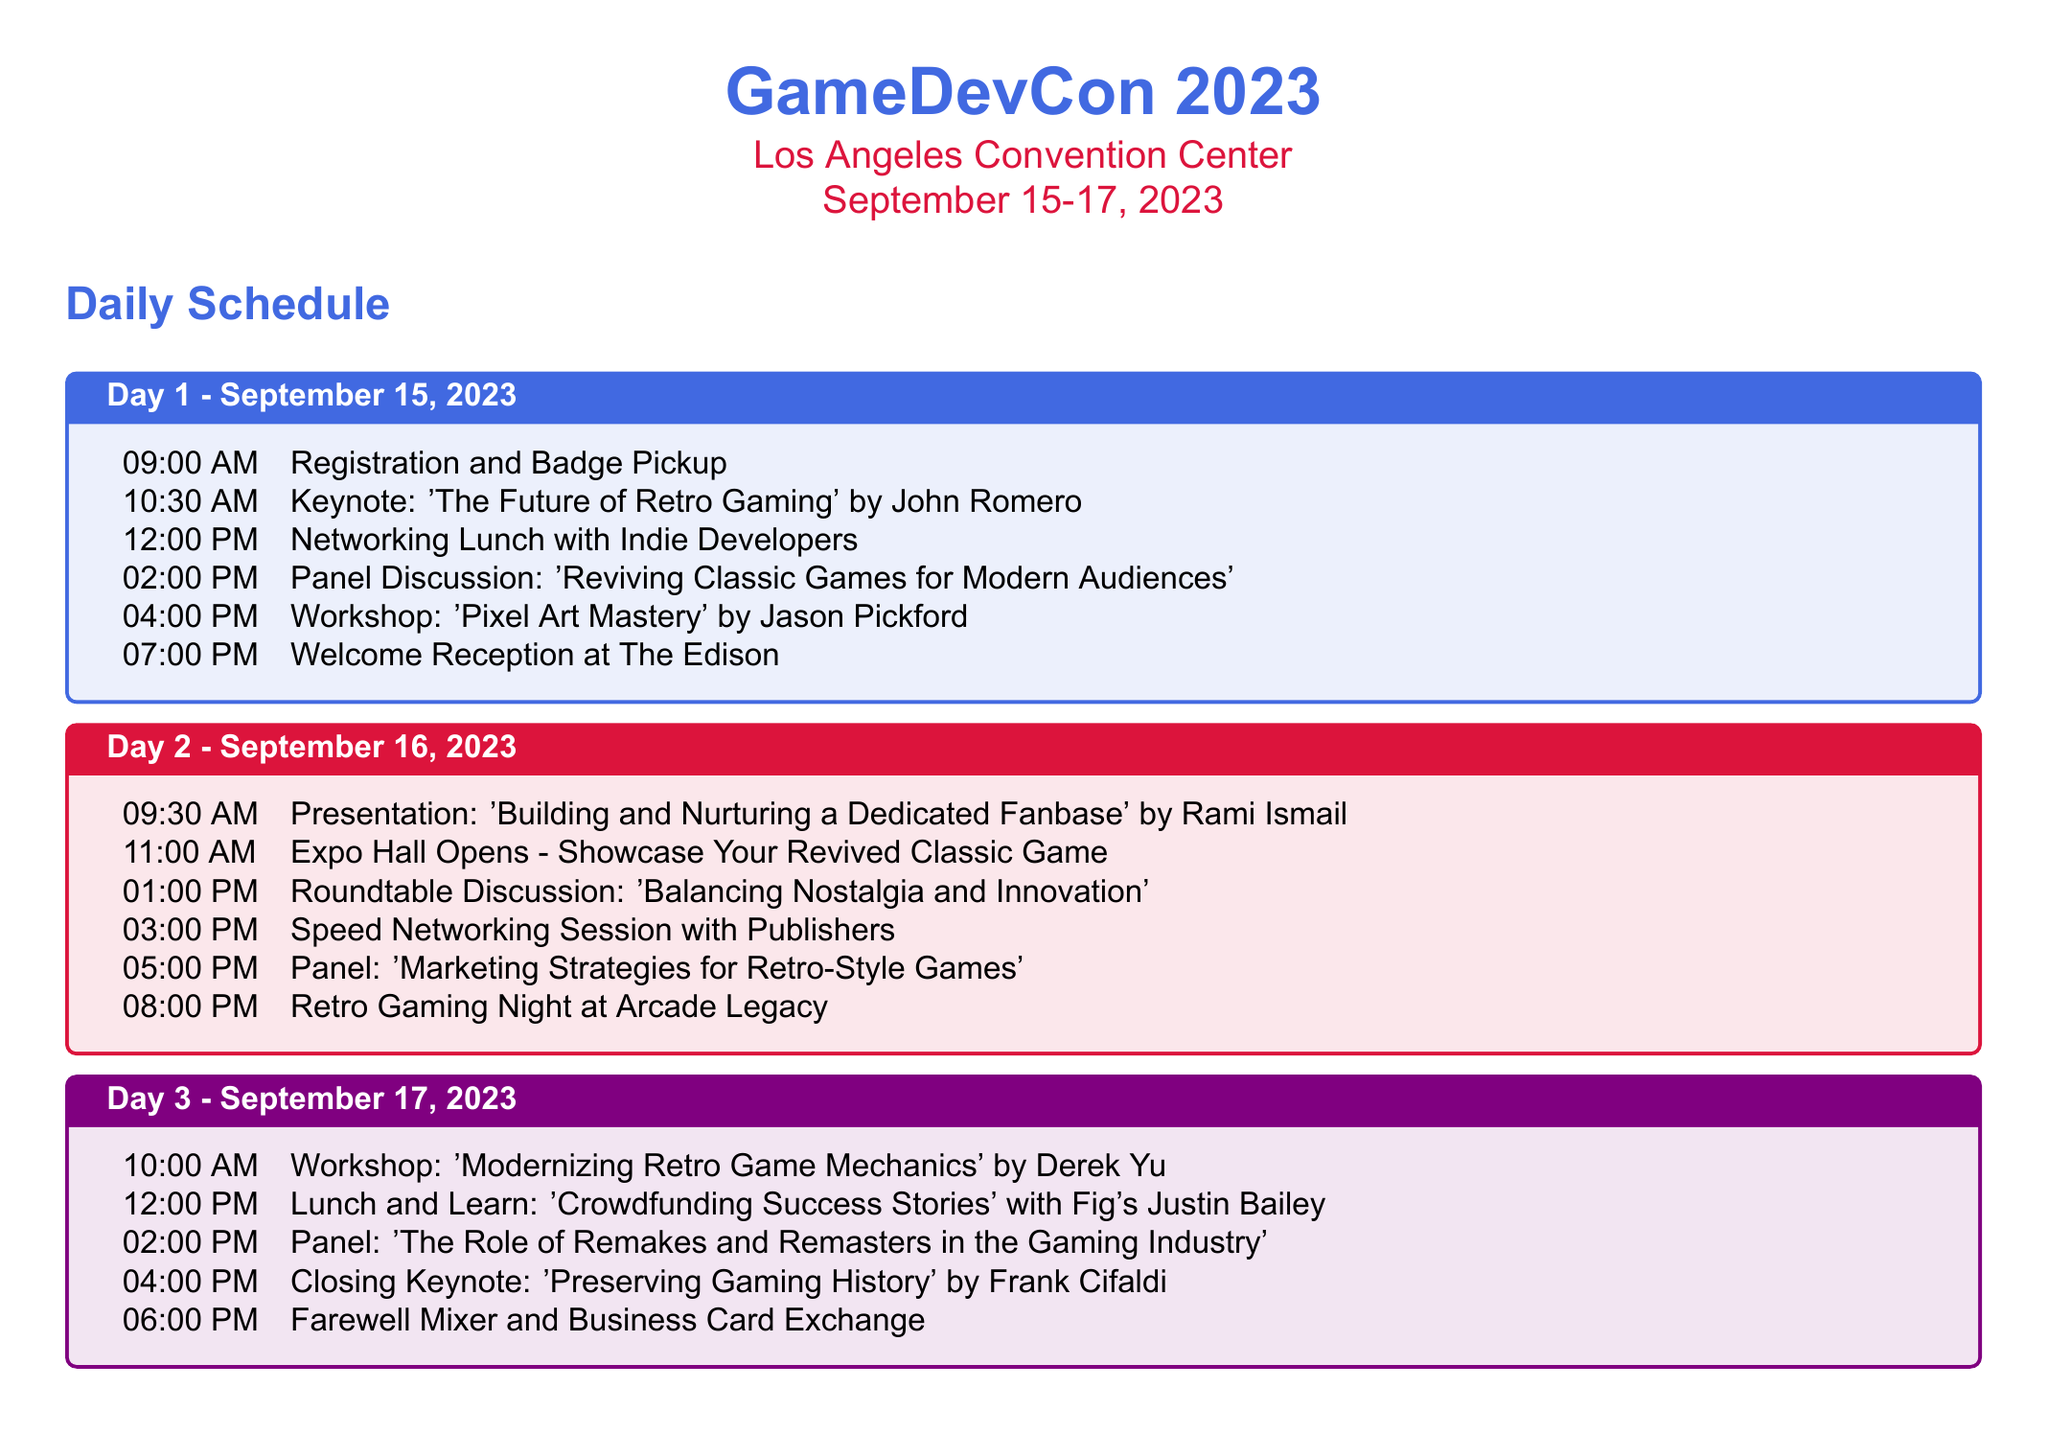What is the name of the conference? The document states the name of the conference at the beginning, which is GameDevCon 2023.
Answer: GameDevCon 2023 What are the dates of the event? The document specifies the date range for the conference: September 15-17, 2023.
Answer: September 15-17, 2023 Who is the keynote speaker on Day 1? The keynote speaker is mentioned in the Day 1 schedule, specifically noted during the Keynote event.
Answer: John Romero What time does the Expo Hall Open on Day 2? The document specifies the time when the Expo Hall opens in the Day 2 schedule.
Answer: 11:00 AM What is the topic of the closing keynote? The closing keynote topic is mentioned in the Day 3 schedule, indicating what Frank Cifaldi will discuss.
Answer: Preserving Gaming History How many workshops are listed in the document? The document lists the number of workshops to attend in a specific section.
Answer: Four What event occurs immediately after the Networking Lunch on Day 1? By reviewing the Day 1 schedule, the event that follows the Networking Lunch can be identified.
Answer: Panel Discussion: 'Reviving Classic Games for Modern Audiences' What is one networking opportunity listed in the document? The document explicitly mentions various networking opportunities in a designated section.
Answer: Indie Developer Showcase Who is one of the key speakers at the conference? The document lists key speakers in a section dedicated to them.
Answer: John Romero 